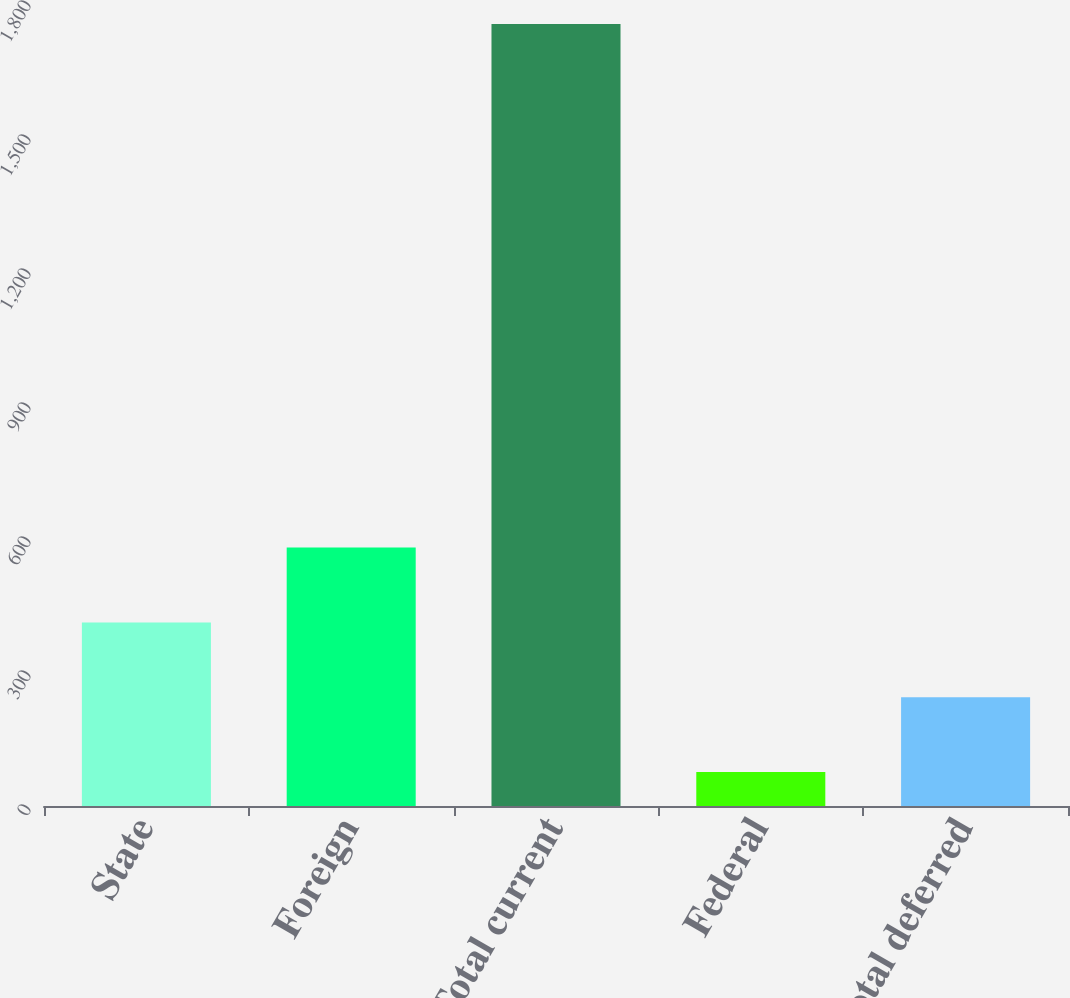<chart> <loc_0><loc_0><loc_500><loc_500><bar_chart><fcel>State<fcel>Foreign<fcel>Total current<fcel>Federal<fcel>Total deferred<nl><fcel>411<fcel>578.5<fcel>1751<fcel>76<fcel>243.5<nl></chart> 